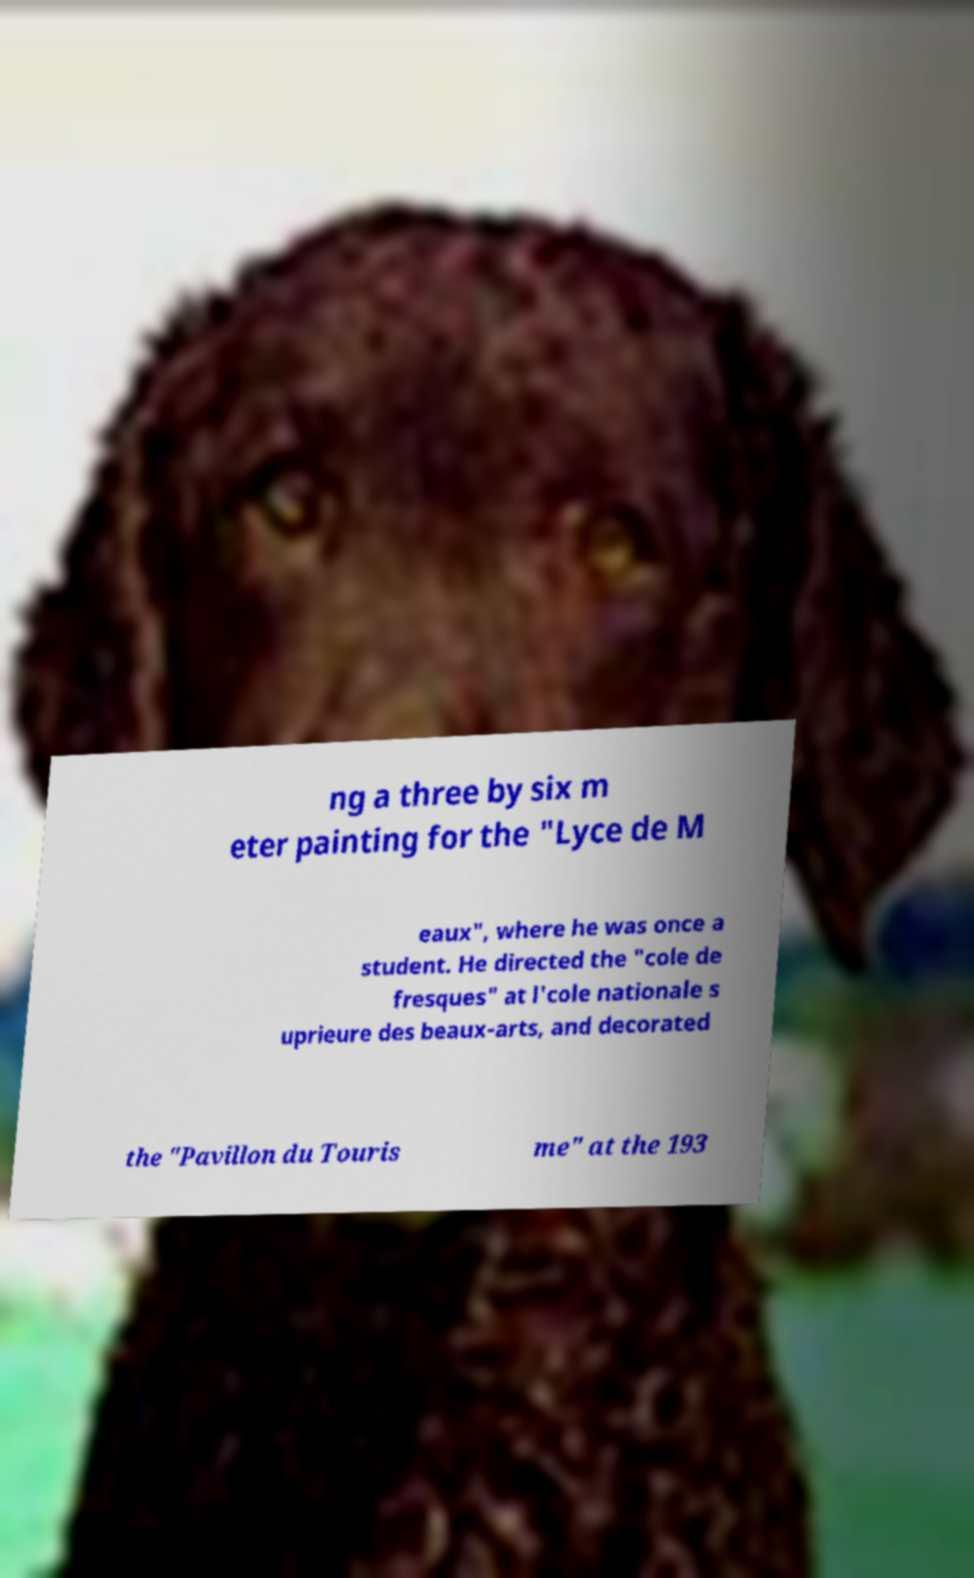Can you accurately transcribe the text from the provided image for me? ng a three by six m eter painting for the "Lyce de M eaux", where he was once a student. He directed the "cole de fresques" at l'cole nationale s uprieure des beaux-arts, and decorated the "Pavillon du Touris me" at the 193 